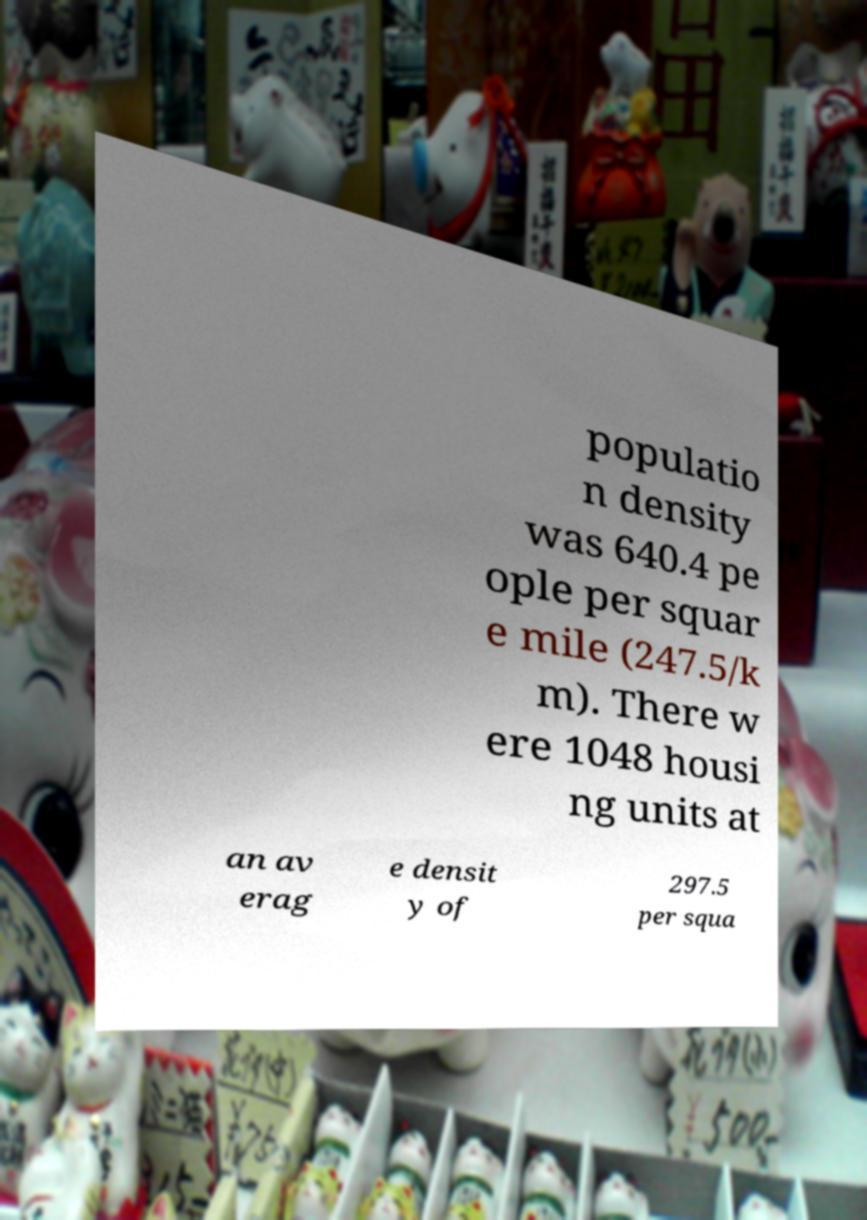What messages or text are displayed in this image? I need them in a readable, typed format. populatio n density was 640.4 pe ople per squar e mile (247.5/k m). There w ere 1048 housi ng units at an av erag e densit y of 297.5 per squa 